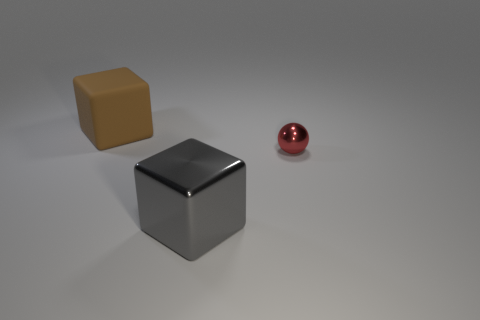Add 2 brown rubber cubes. How many objects exist? 5 Subtract all blocks. How many objects are left? 1 Subtract all blue metal objects. Subtract all matte objects. How many objects are left? 2 Add 3 red shiny things. How many red shiny things are left? 4 Add 2 red spheres. How many red spheres exist? 3 Subtract 0 purple balls. How many objects are left? 3 